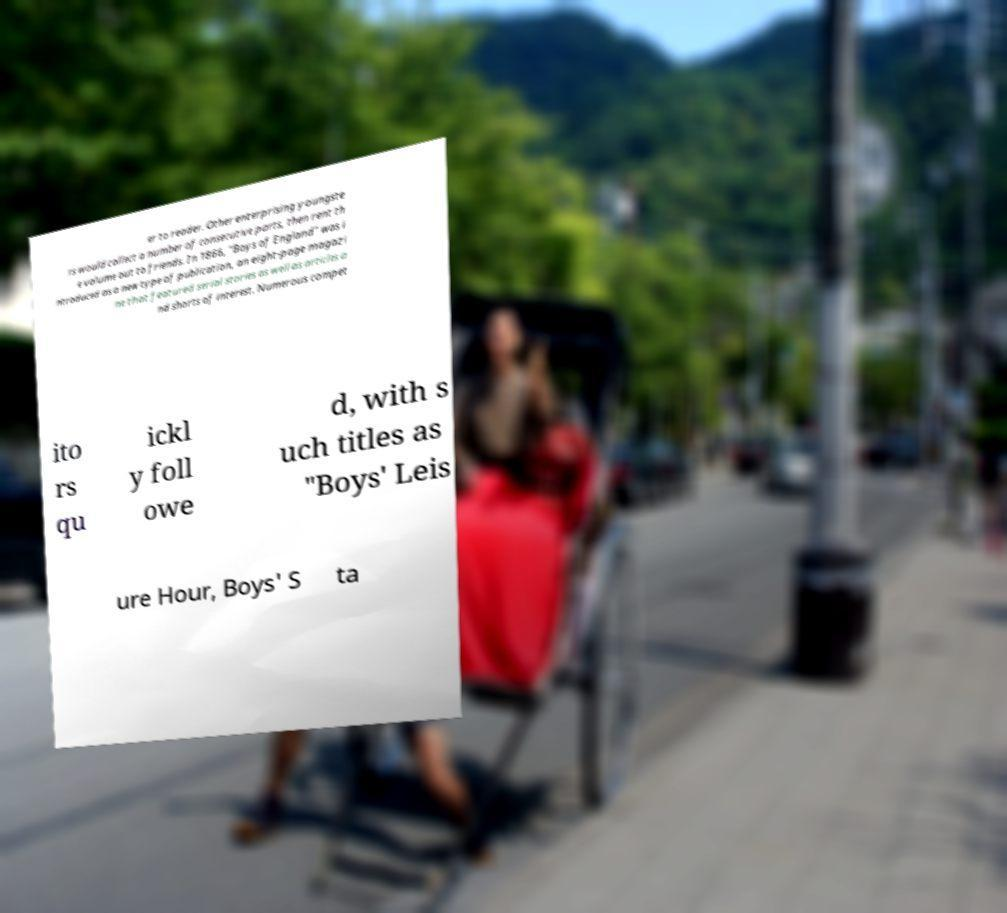I need the written content from this picture converted into text. Can you do that? er to reader. Other enterprising youngste rs would collect a number of consecutive parts, then rent th e volume out to friends. In 1866, "Boys of England" was i ntroduced as a new type of publication, an eight-page magazi ne that featured serial stories as well as articles a nd shorts of interest. Numerous compet ito rs qu ickl y foll owe d, with s uch titles as "Boys' Leis ure Hour, Boys' S ta 